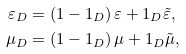<formula> <loc_0><loc_0><loc_500><loc_500>\varepsilon _ { D } & = \left ( 1 - 1 _ { D } \right ) \varepsilon + 1 _ { D } \tilde { \varepsilon } , \\ \mu _ { D } & = \left ( 1 - 1 _ { D } \right ) \mu + 1 _ { D } \tilde { \mu } ,</formula> 